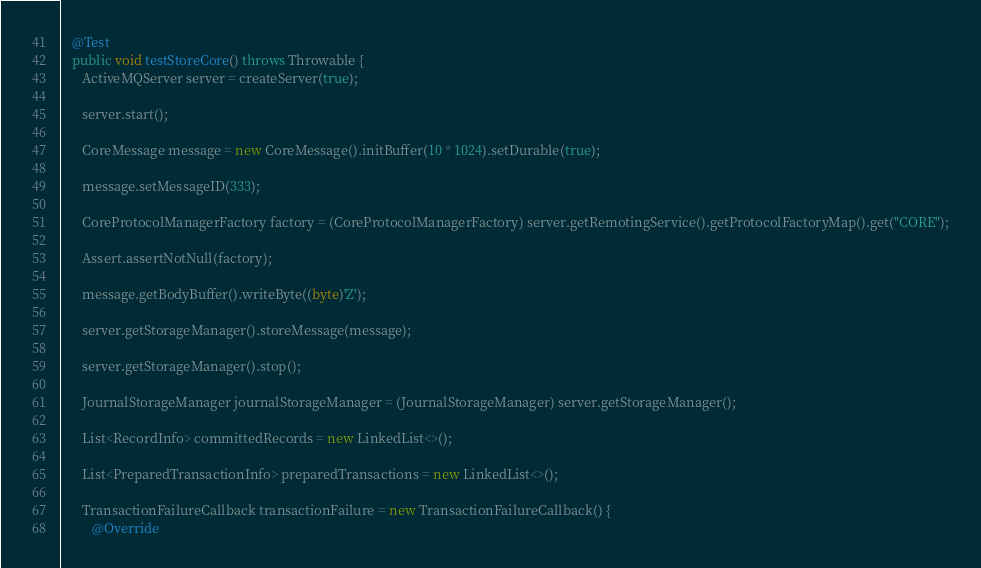Convert code to text. <code><loc_0><loc_0><loc_500><loc_500><_Java_>   @Test
   public void testStoreCore() throws Throwable {
      ActiveMQServer server = createServer(true);

      server.start();

      CoreMessage message = new CoreMessage().initBuffer(10 * 1024).setDurable(true);

      message.setMessageID(333);

      CoreProtocolManagerFactory factory = (CoreProtocolManagerFactory) server.getRemotingService().getProtocolFactoryMap().get("CORE");

      Assert.assertNotNull(factory);

      message.getBodyBuffer().writeByte((byte)'Z');

      server.getStorageManager().storeMessage(message);

      server.getStorageManager().stop();

      JournalStorageManager journalStorageManager = (JournalStorageManager) server.getStorageManager();

      List<RecordInfo> committedRecords = new LinkedList<>();

      List<PreparedTransactionInfo> preparedTransactions = new LinkedList<>();

      TransactionFailureCallback transactionFailure = new TransactionFailureCallback() {
         @Override</code> 